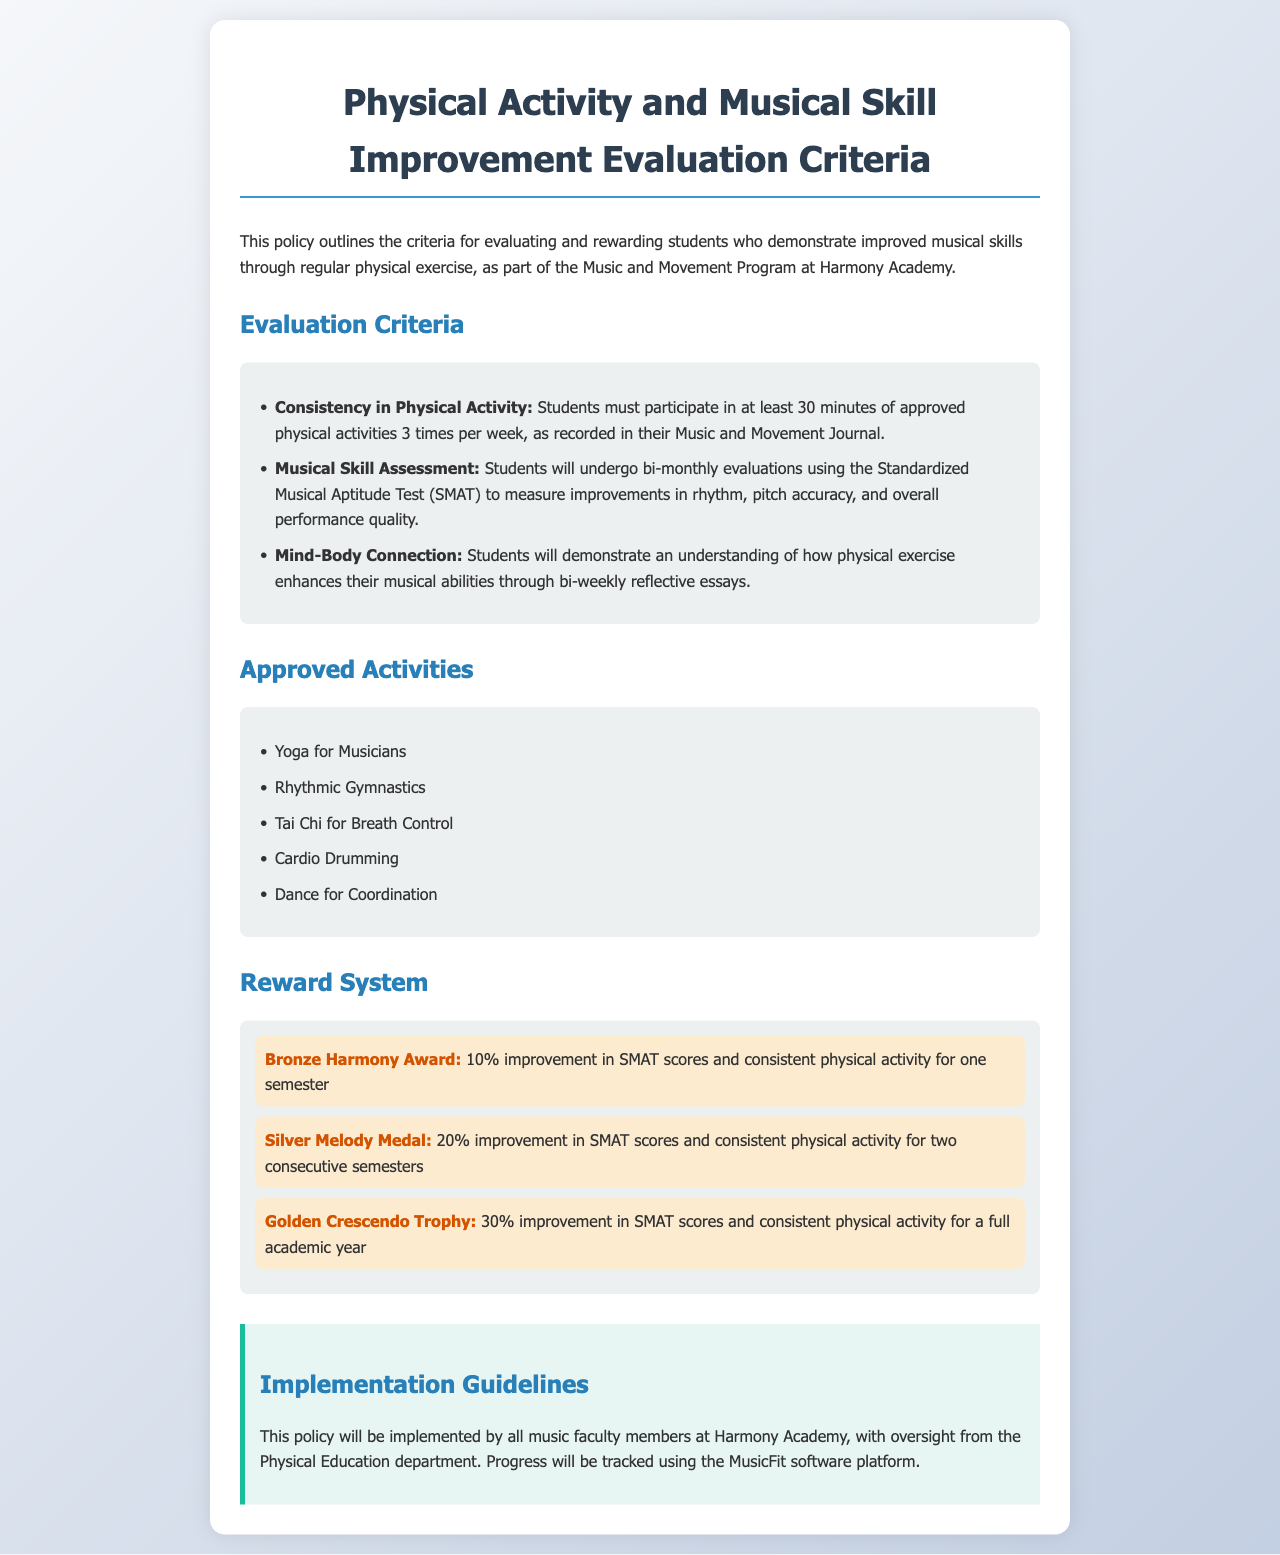What is the minimum physical activity requirement per week? The document states that students must participate in at least 30 minutes of approved physical activities 3 times per week.
Answer: 30 minutes, 3 times What is the assessment frequency for musical skill? The policy outlines that students will undergo bi-monthly evaluations using the Standardized Musical Aptitude Test.
Answer: Bi-monthly Which activity is included in the approved activities? The document lists several approved activities, one of which is "Yoga for Musicians."
Answer: Yoga for Musicians What improvement percentage is needed for the Bronze Harmony Award? The document specifies that a 10% improvement in SMAT scores is required for the Bronze Harmony Award.
Answer: 10% Who oversees the implementation of the policy? It is stated that all music faculty members at Harmony Academy, with oversight from the Physical Education department, will implement this policy.
Answer: Physical Education department How many consecutive semesters are required for the Silver Melody Medal? The policy mentions that consistent physical activity for two consecutive semesters is needed to qualify for the Silver Melody Medal.
Answer: Two consecutive semesters What software platform will track progress? The document mentions that progress will be tracked using the MusicFit software platform.
Answer: MusicFit What is the highest reward mentioned in the document? The highest reward described is the "Golden Crescendo Trophy."
Answer: Golden Crescendo Trophy 